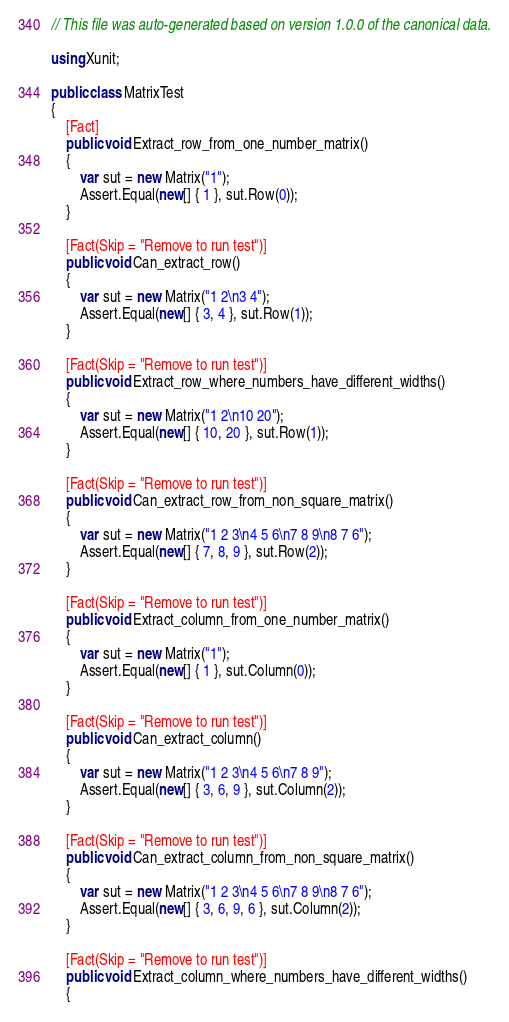<code> <loc_0><loc_0><loc_500><loc_500><_C#_>// This file was auto-generated based on version 1.0.0 of the canonical data.

using Xunit;

public class MatrixTest
{
    [Fact]
    public void Extract_row_from_one_number_matrix()
    {
        var sut = new Matrix("1");
        Assert.Equal(new[] { 1 }, sut.Row(0));
    }

    [Fact(Skip = "Remove to run test")]
    public void Can_extract_row()
    {
        var sut = new Matrix("1 2\n3 4");
        Assert.Equal(new[] { 3, 4 }, sut.Row(1));
    }

    [Fact(Skip = "Remove to run test")]
    public void Extract_row_where_numbers_have_different_widths()
    {
        var sut = new Matrix("1 2\n10 20");
        Assert.Equal(new[] { 10, 20 }, sut.Row(1));
    }

    [Fact(Skip = "Remove to run test")]
    public void Can_extract_row_from_non_square_matrix()
    {
        var sut = new Matrix("1 2 3\n4 5 6\n7 8 9\n8 7 6");
        Assert.Equal(new[] { 7, 8, 9 }, sut.Row(2));
    }

    [Fact(Skip = "Remove to run test")]
    public void Extract_column_from_one_number_matrix()
    {
        var sut = new Matrix("1");
        Assert.Equal(new[] { 1 }, sut.Column(0));
    }

    [Fact(Skip = "Remove to run test")]
    public void Can_extract_column()
    {
        var sut = new Matrix("1 2 3\n4 5 6\n7 8 9");
        Assert.Equal(new[] { 3, 6, 9 }, sut.Column(2));
    }

    [Fact(Skip = "Remove to run test")]
    public void Can_extract_column_from_non_square_matrix()
    {
        var sut = new Matrix("1 2 3\n4 5 6\n7 8 9\n8 7 6");
        Assert.Equal(new[] { 3, 6, 9, 6 }, sut.Column(2));
    }

    [Fact(Skip = "Remove to run test")]
    public void Extract_column_where_numbers_have_different_widths()
    {</code> 